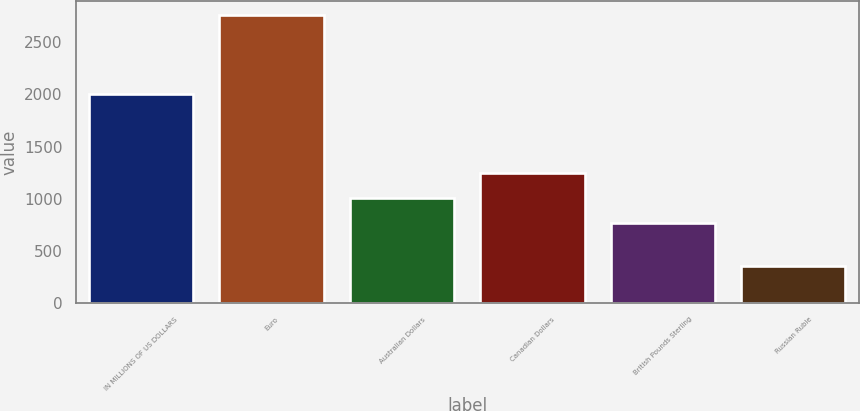Convert chart to OTSL. <chart><loc_0><loc_0><loc_500><loc_500><bar_chart><fcel>IN MILLIONS OF US DOLLARS<fcel>Euro<fcel>Australian Dollars<fcel>Canadian Dollars<fcel>British Pounds Sterling<fcel>Russian Ruble<nl><fcel>2006<fcel>2758<fcel>1009.9<fcel>1249.8<fcel>770<fcel>359<nl></chart> 